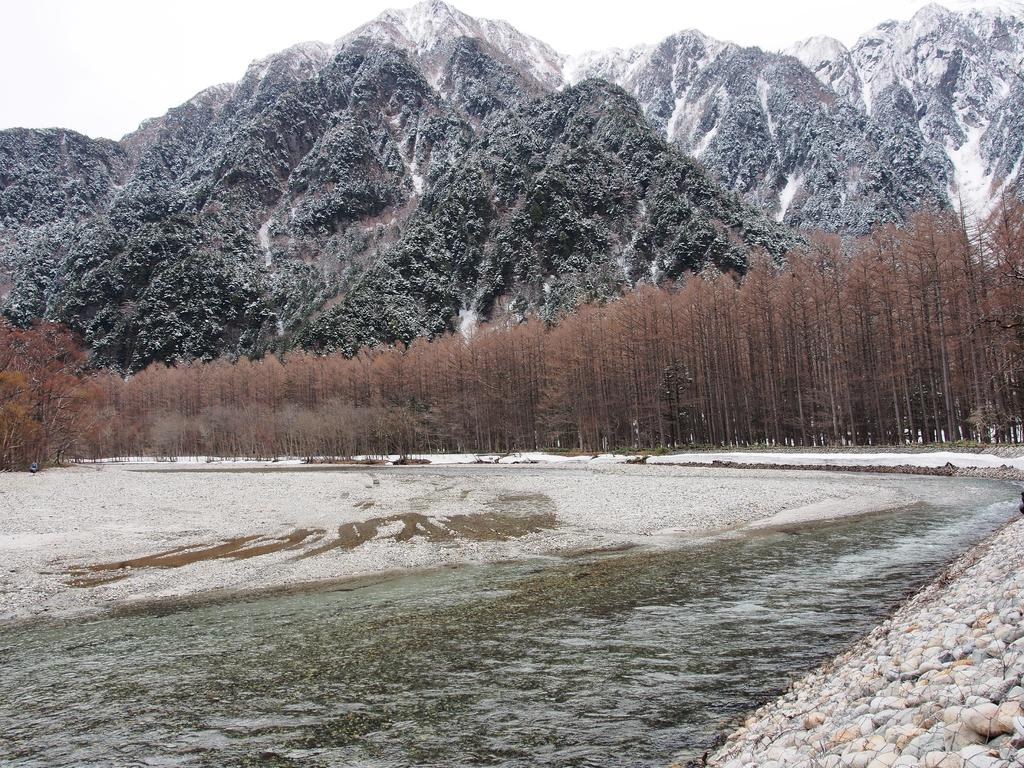What natural elements can be seen in the image? There is water, sand, stones, trees, and mountains visible in the image. What type of terrain is depicted in the image? The image shows a combination of water, sand, and stones, which suggests a beach or shoreline. What is visible in the sky in the image? The sky is visible in the image. Can you describe the vegetation in the image? There are trees present in the image. What type of stage can be seen in the image? There is no stage present in the image; it features natural elements such as water, sand, stones, trees, and mountains. How many springs are visible in the image? There are no springs visible in the image; it shows a natural landscape with water, sand, stones, trees, and mountains. 